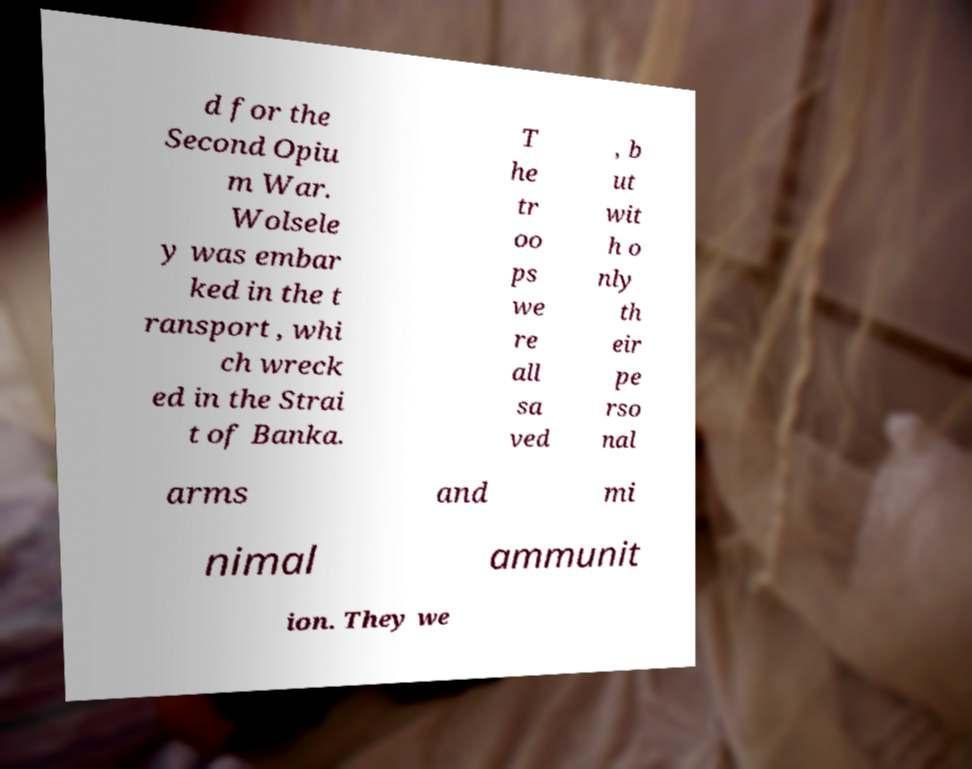For documentation purposes, I need the text within this image transcribed. Could you provide that? d for the Second Opiu m War. Wolsele y was embar ked in the t ransport , whi ch wreck ed in the Strai t of Banka. T he tr oo ps we re all sa ved , b ut wit h o nly th eir pe rso nal arms and mi nimal ammunit ion. They we 